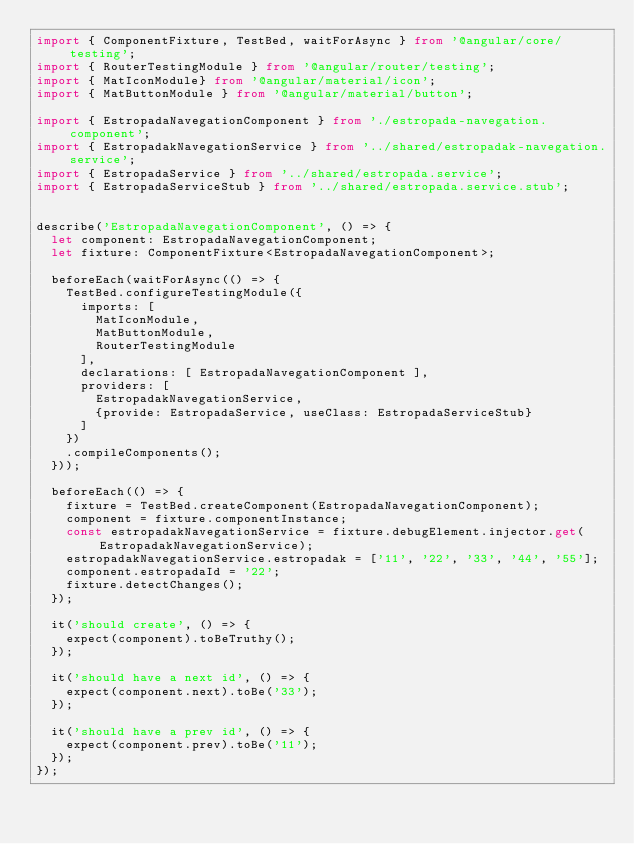Convert code to text. <code><loc_0><loc_0><loc_500><loc_500><_TypeScript_>import { ComponentFixture, TestBed, waitForAsync } from '@angular/core/testing';
import { RouterTestingModule } from '@angular/router/testing';
import { MatIconModule} from '@angular/material/icon'; 
import { MatButtonModule } from '@angular/material/button';

import { EstropadaNavegationComponent } from './estropada-navegation.component';
import { EstropadakNavegationService } from '../shared/estropadak-navegation.service';
import { EstropadaService } from '../shared/estropada.service';
import { EstropadaServiceStub } from '../shared/estropada.service.stub';


describe('EstropadaNavegationComponent', () => {
  let component: EstropadaNavegationComponent;
  let fixture: ComponentFixture<EstropadaNavegationComponent>;

  beforeEach(waitForAsync(() => {
    TestBed.configureTestingModule({
      imports: [
        MatIconModule,
        MatButtonModule,
        RouterTestingModule
      ],
      declarations: [ EstropadaNavegationComponent ],
      providers: [
        EstropadakNavegationService,
        {provide: EstropadaService, useClass: EstropadaServiceStub}
      ]
    })
    .compileComponents();
  }));

  beforeEach(() => {
    fixture = TestBed.createComponent(EstropadaNavegationComponent);
    component = fixture.componentInstance;
    const estropadakNavegationService = fixture.debugElement.injector.get(EstropadakNavegationService);
    estropadakNavegationService.estropadak = ['11', '22', '33', '44', '55'];
    component.estropadaId = '22';
    fixture.detectChanges();
  });

  it('should create', () => {
    expect(component).toBeTruthy();
  });

  it('should have a next id', () => {
    expect(component.next).toBe('33');
  });

  it('should have a prev id', () => {
    expect(component.prev).toBe('11');
  });
});
</code> 